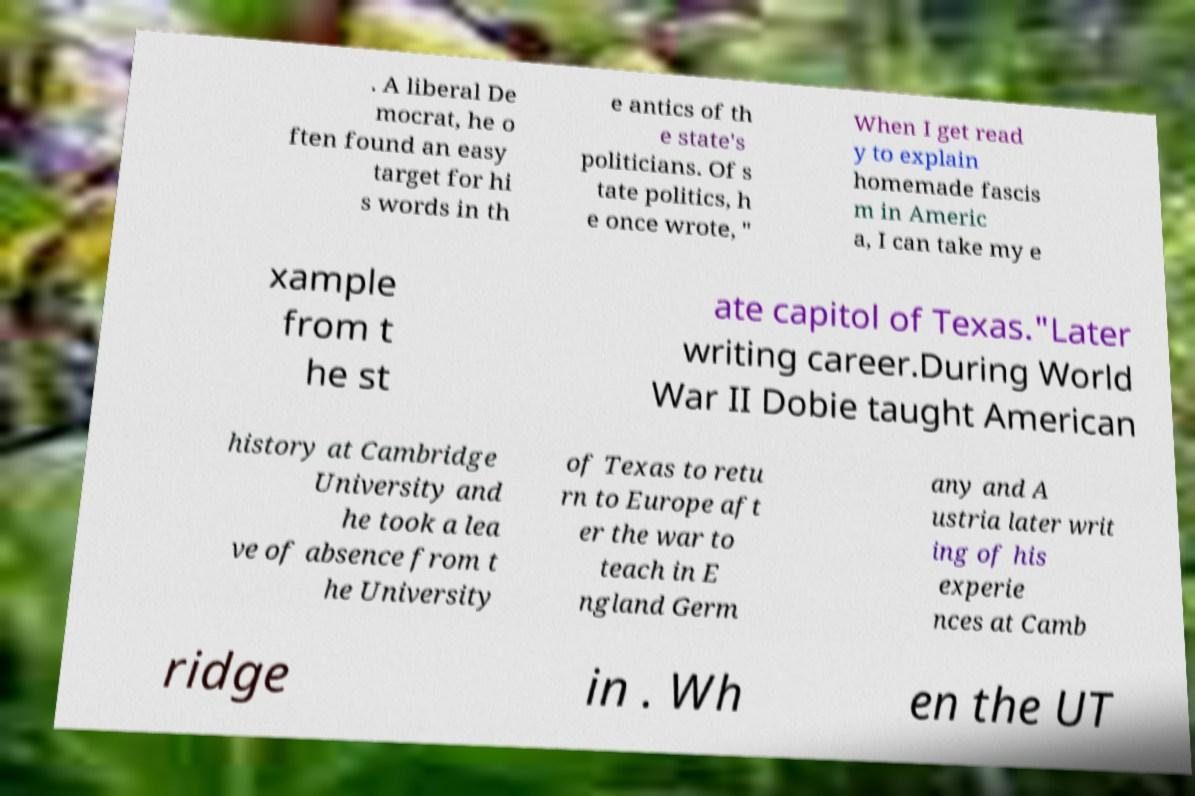Please identify and transcribe the text found in this image. . A liberal De mocrat, he o ften found an easy target for hi s words in th e antics of th e state's politicians. Of s tate politics, h e once wrote, " When I get read y to explain homemade fascis m in Americ a, I can take my e xample from t he st ate capitol of Texas."Later writing career.During World War II Dobie taught American history at Cambridge University and he took a lea ve of absence from t he University of Texas to retu rn to Europe aft er the war to teach in E ngland Germ any and A ustria later writ ing of his experie nces at Camb ridge in . Wh en the UT 